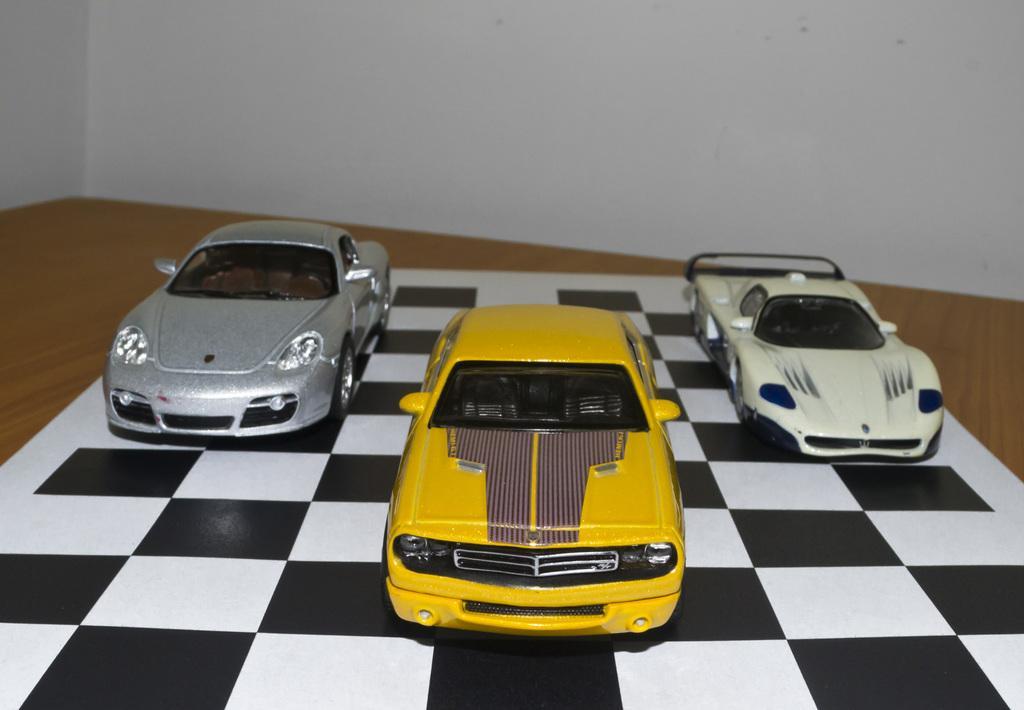Could you give a brief overview of what you see in this image? In the foreground of this picture, there are three toy cars on a chess board which is on the table. In the background, there is a wall. 